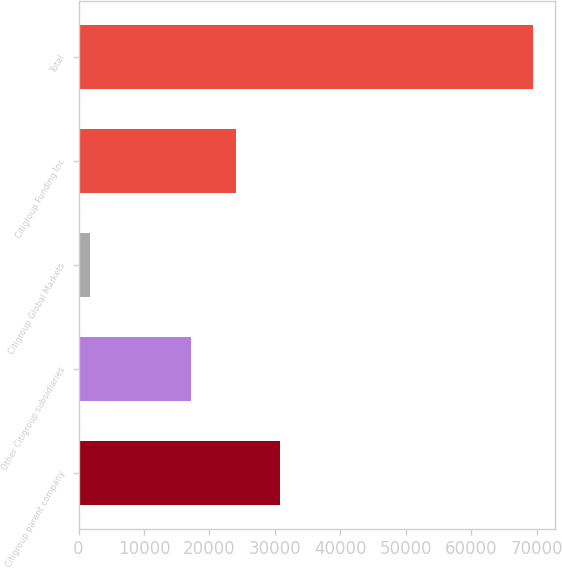Convert chart to OTSL. <chart><loc_0><loc_0><loc_500><loc_500><bar_chart><fcel>Citigroup parent company<fcel>Other Citigroup subsidiaries<fcel>Citigroup Global Markets<fcel>Citigroup Funding Inc<fcel>Total<nl><fcel>30745.6<fcel>17214<fcel>1686<fcel>23979.8<fcel>69344<nl></chart> 